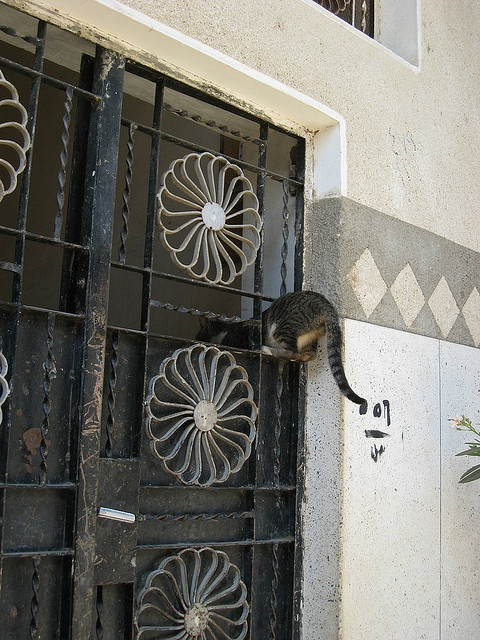Describe the objects in this image and their specific colors. I can see a cat in tan, black, gray, and lightgray tones in this image. 